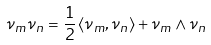<formula> <loc_0><loc_0><loc_500><loc_500>\nu _ { m } \nu _ { n } = \frac { 1 } { 2 } \left \langle { \nu } _ { m } , { \nu } _ { n } \right \rangle + { \nu } _ { m } \wedge { \nu } _ { n }</formula> 